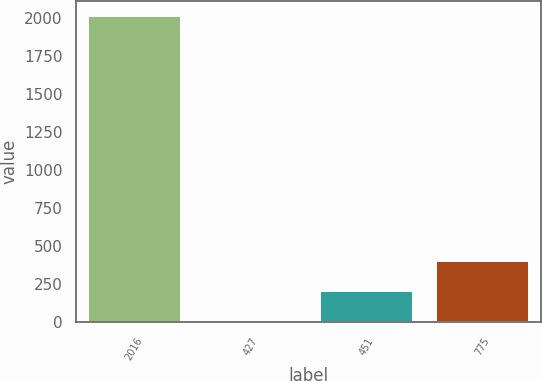Convert chart to OTSL. <chart><loc_0><loc_0><loc_500><loc_500><bar_chart><fcel>2016<fcel>427<fcel>451<fcel>775<nl><fcel>2014<fcel>4.14<fcel>205.13<fcel>406.12<nl></chart> 